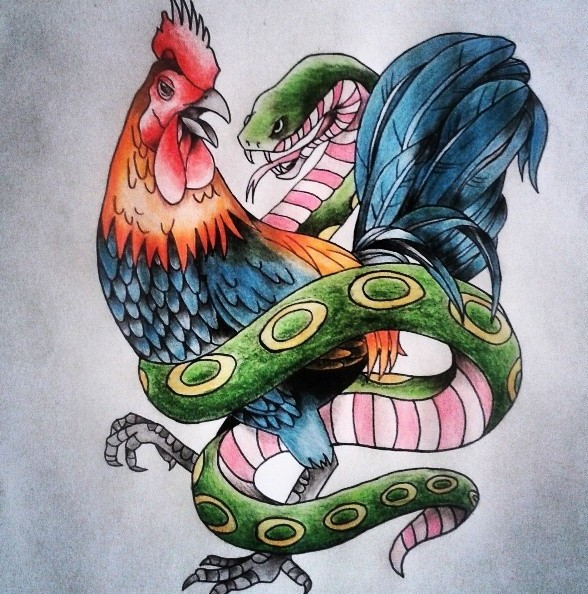Imagine this image is part of a larger mural. What kind of story might the mural be telling? If this image were part of a larger mural, it might be telling a story of balance and transformation. Each section of the mural could depict different pairs of animals or elements representing various dualities in life: day and night, sky and earth, fire and water. This particular segment, with the rooster and snake, might focus on the theme of vigilance against temptation, or the cycle of death and rebirth. The mural as a whole could weave these individual stories into a grand narrative about the interconnectedness of all things and the eternal dance between opposing forces. 